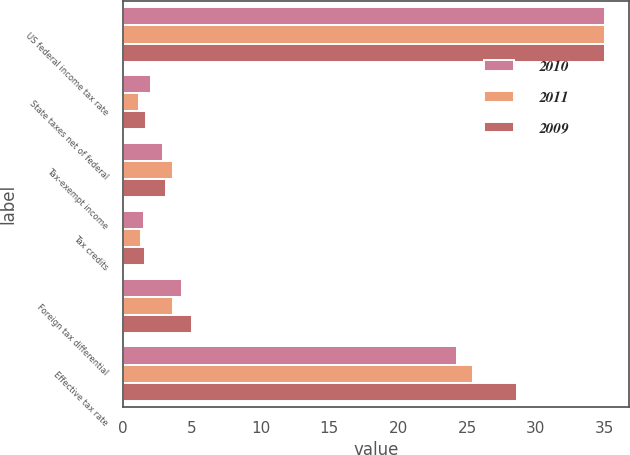Convert chart to OTSL. <chart><loc_0><loc_0><loc_500><loc_500><stacked_bar_chart><ecel><fcel>US federal income tax rate<fcel>State taxes net of federal<fcel>Tax-exempt income<fcel>Tax credits<fcel>Foreign tax differential<fcel>Effective tax rate<nl><fcel>2010<fcel>35<fcel>2<fcel>2.9<fcel>1.5<fcel>4.3<fcel>24.3<nl><fcel>2011<fcel>35<fcel>1.2<fcel>3.6<fcel>1.3<fcel>3.6<fcel>25.4<nl><fcel>2009<fcel>35<fcel>1.7<fcel>3.1<fcel>1.6<fcel>5<fcel>28.6<nl></chart> 